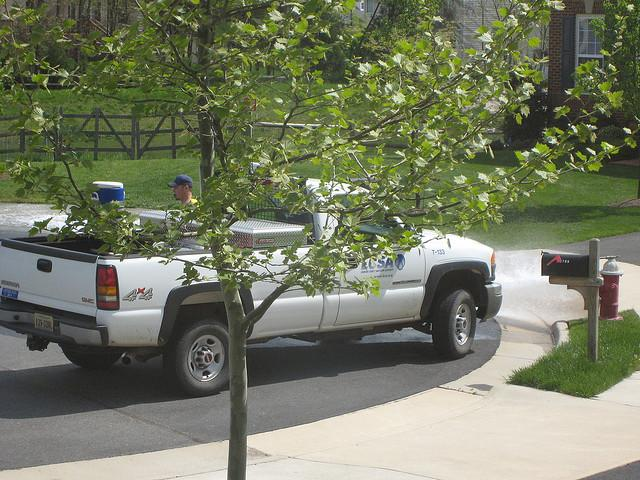What does he do? Please explain your reasoning. landscaping. The man takes care of trees. 